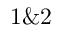<formula> <loc_0><loc_0><loc_500><loc_500>1 \& 2</formula> 